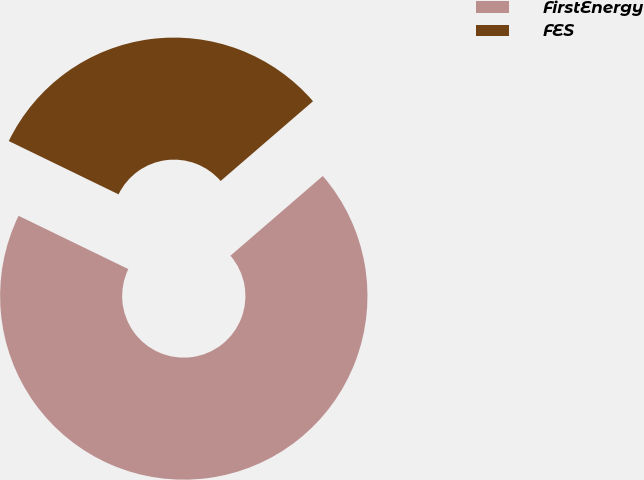Convert chart to OTSL. <chart><loc_0><loc_0><loc_500><loc_500><pie_chart><fcel>FirstEnergy<fcel>FES<nl><fcel>68.53%<fcel>31.47%<nl></chart> 